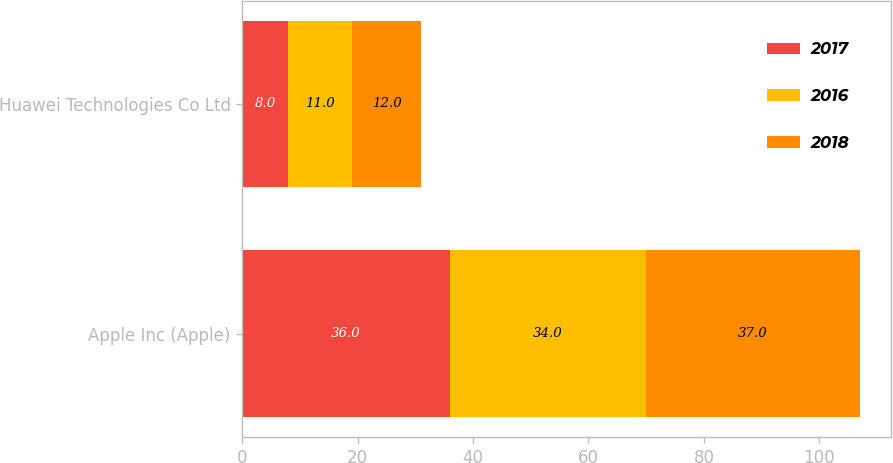<chart> <loc_0><loc_0><loc_500><loc_500><stacked_bar_chart><ecel><fcel>Apple Inc (Apple)<fcel>Huawei Technologies Co Ltd<nl><fcel>2017<fcel>36<fcel>8<nl><fcel>2016<fcel>34<fcel>11<nl><fcel>2018<fcel>37<fcel>12<nl></chart> 